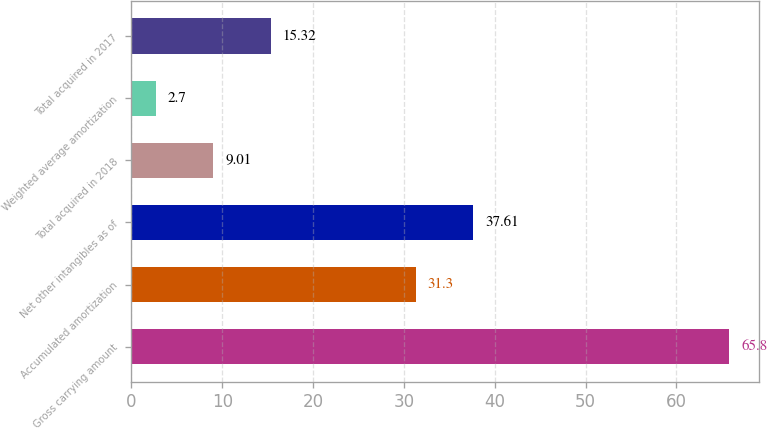Convert chart to OTSL. <chart><loc_0><loc_0><loc_500><loc_500><bar_chart><fcel>Gross carrying amount<fcel>Accumulated amortization<fcel>Net other intangibles as of<fcel>Total acquired in 2018<fcel>Weighted average amortization<fcel>Total acquired in 2017<nl><fcel>65.8<fcel>31.3<fcel>37.61<fcel>9.01<fcel>2.7<fcel>15.32<nl></chart> 